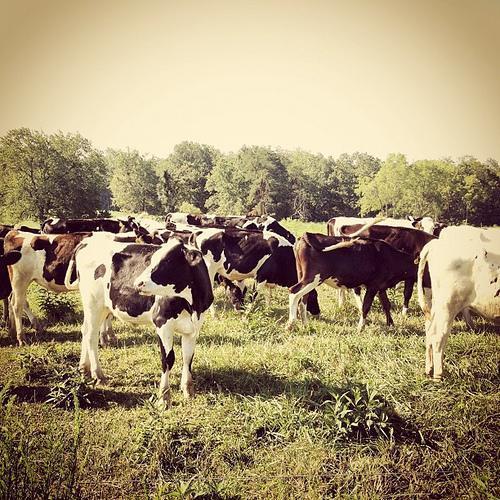How many horns on the cow facing the camera?
Give a very brief answer. 0. 